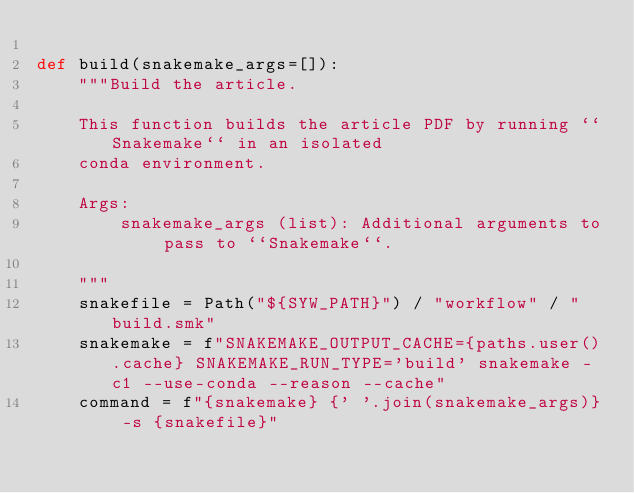<code> <loc_0><loc_0><loc_500><loc_500><_Python_>
def build(snakemake_args=[]):
    """Build the article.

    This function builds the article PDF by running ``Snakemake`` in an isolated
    conda environment.

    Args:
        snakemake_args (list): Additional arguments to pass to ``Snakemake``.

    """
    snakefile = Path("${SYW_PATH}") / "workflow" / "build.smk"
    snakemake = f"SNAKEMAKE_OUTPUT_CACHE={paths.user().cache} SNAKEMAKE_RUN_TYPE='build' snakemake -c1 --use-conda --reason --cache"
    command = f"{snakemake} {' '.join(snakemake_args)} -s {snakefile}"</code> 